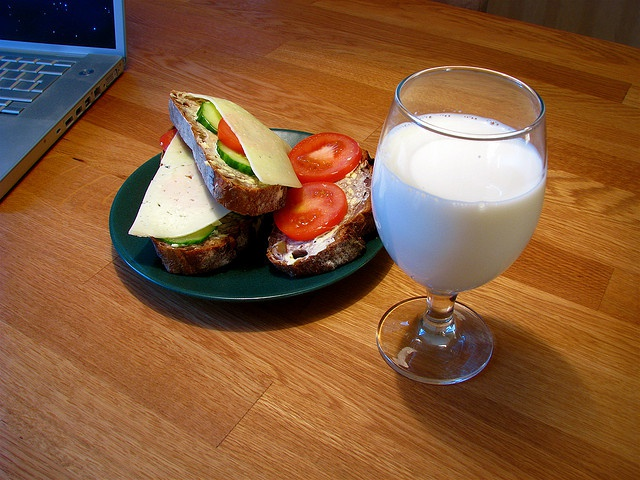Describe the objects in this image and their specific colors. I can see dining table in brown, navy, maroon, and gray tones, wine glass in navy, white, gray, olive, and maroon tones, laptop in navy, black, blue, gray, and maroon tones, sandwich in navy, red, black, and maroon tones, and sandwich in navy, khaki, maroon, tan, and brown tones in this image. 